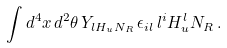Convert formula to latex. <formula><loc_0><loc_0><loc_500><loc_500>\int d ^ { 4 } x \, d ^ { 2 } \theta \, Y _ { l H _ { u } N _ { R } } \, \epsilon _ { i l } \, l ^ { i } H ^ { l } _ { u } N _ { R } \, .</formula> 